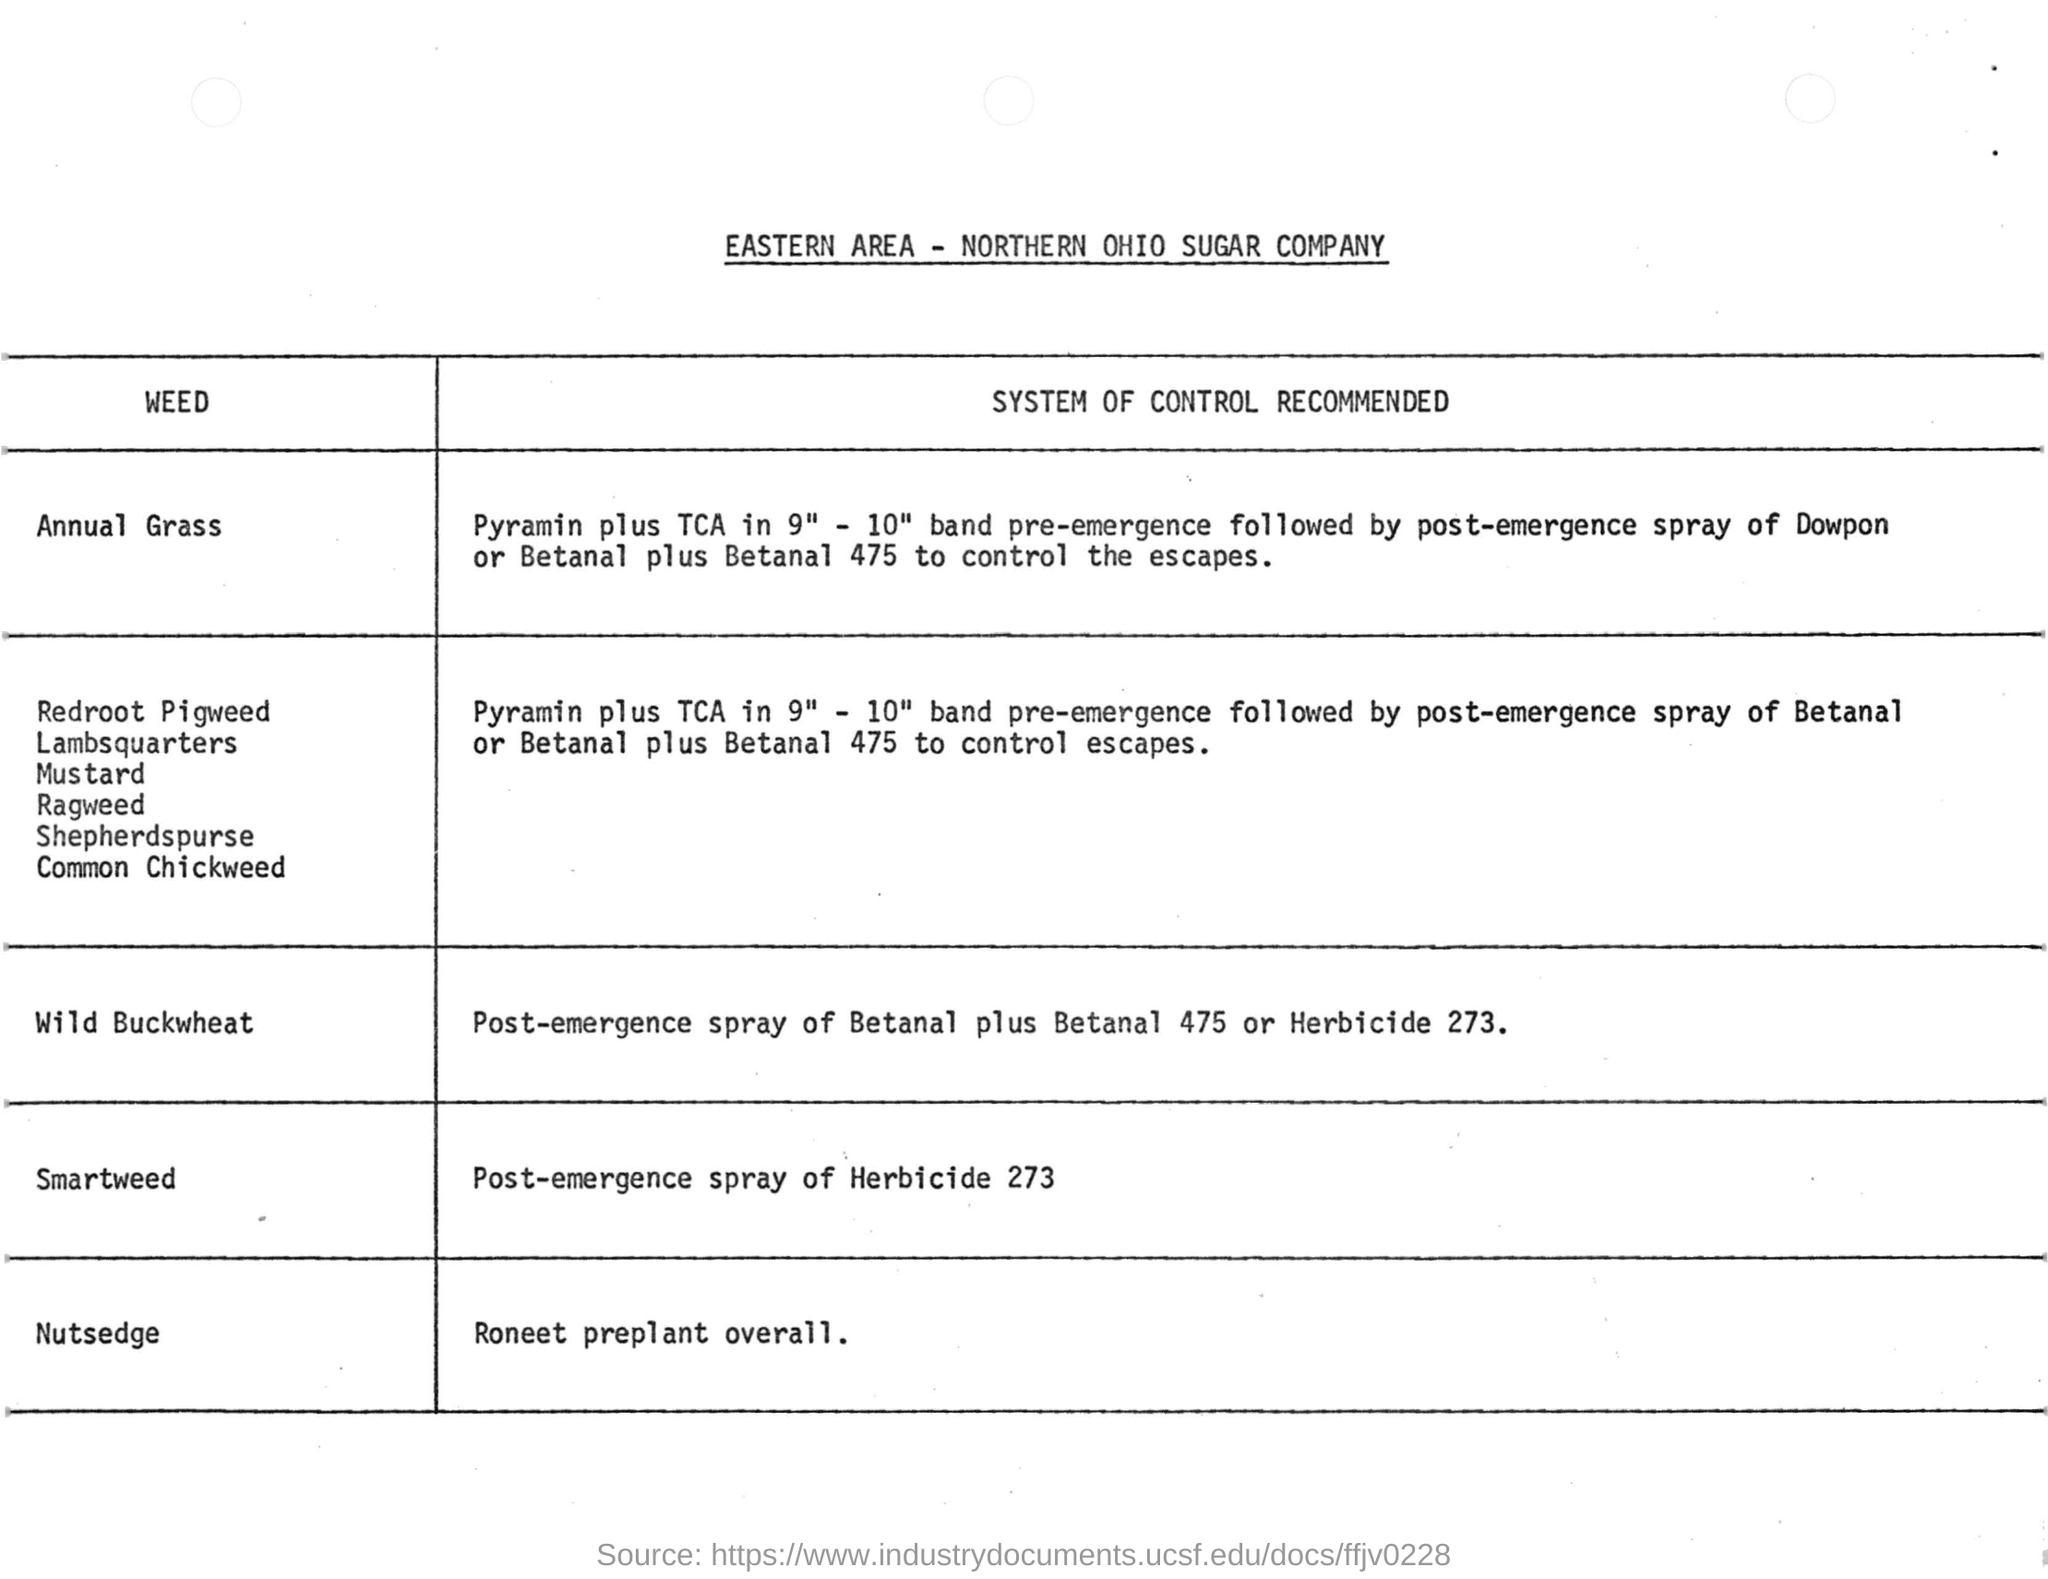What is the system of control recommended for Nutsedge?
Provide a succinct answer. Roneet preplant overall. Post-emergence spray of Herbicide 273 is recommended for which weed?
Your answer should be compact. Smartweed. What is the name of the company in the document?
Keep it short and to the point. NORTHERN OHIO SUGAR COMPANY. Post-emergence of Dowpon is recommended for which weed?
Provide a succinct answer. Annual Grass. 